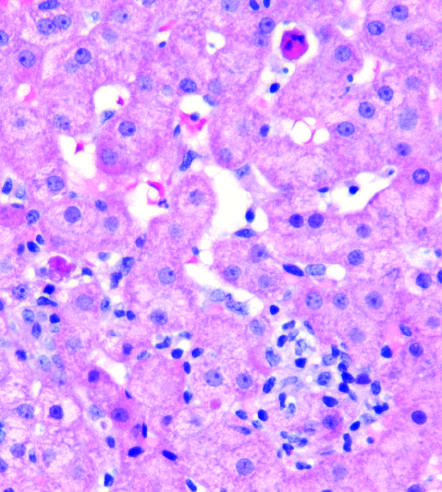does acute rheumatic mitral valvulitis show scattered apoptotic hepatocytes and a patchy inflammatory infiltrate double?
Answer the question using a single word or phrase. No 